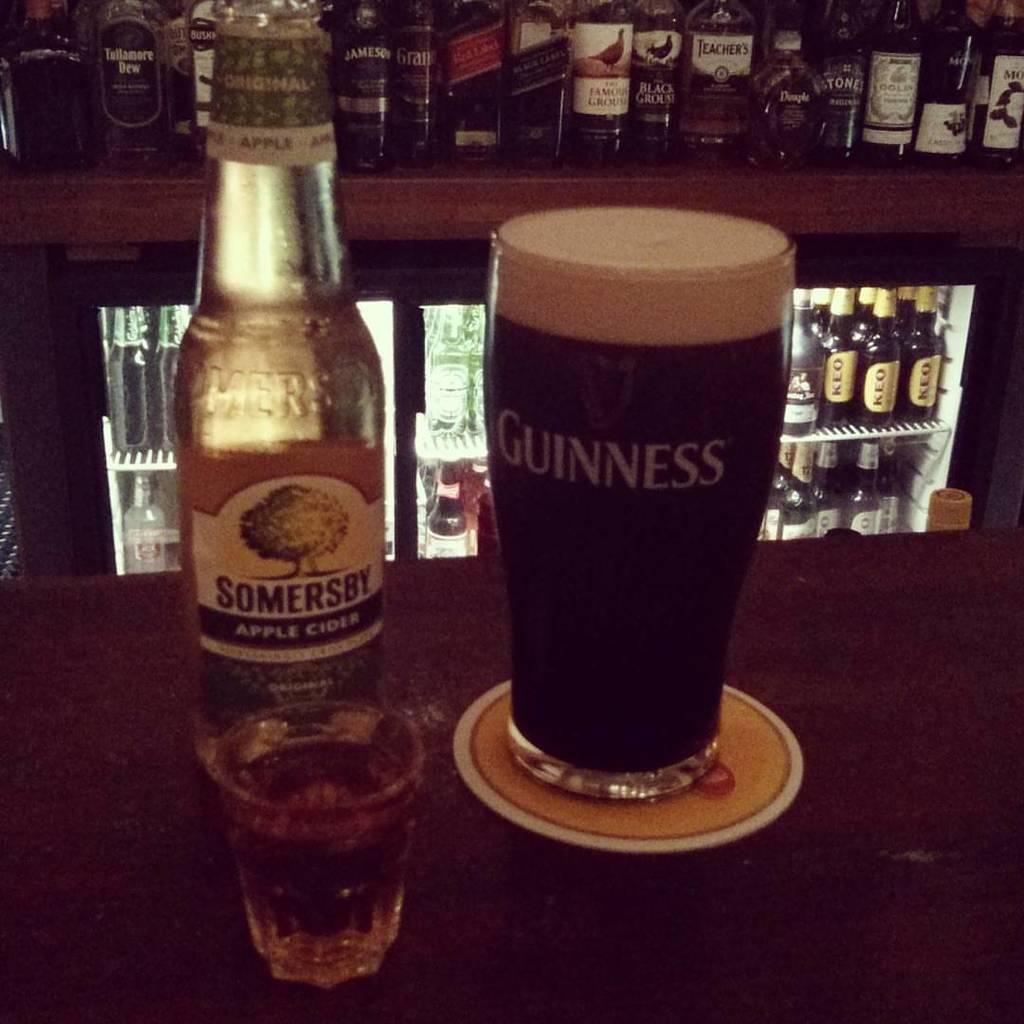Can you describe this image briefly? In this image I can see a wine bottle and two glasses. To the wine glass there is a sticker attached. And on the glass there is a name called Guinness. In the back ground there is a wine rack and many wine bottles in it. 